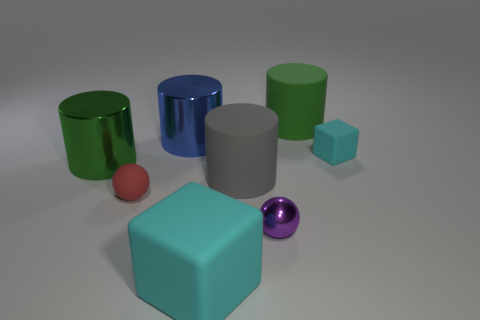Subtract all green cylinders. Subtract all red cubes. How many cylinders are left? 2 Add 2 big blue shiny things. How many objects exist? 10 Subtract all balls. How many objects are left? 6 Add 5 big gray cylinders. How many big gray cylinders are left? 6 Add 1 tiny purple balls. How many tiny purple balls exist? 2 Subtract 0 blue blocks. How many objects are left? 8 Subtract all small blocks. Subtract all green rubber cylinders. How many objects are left? 6 